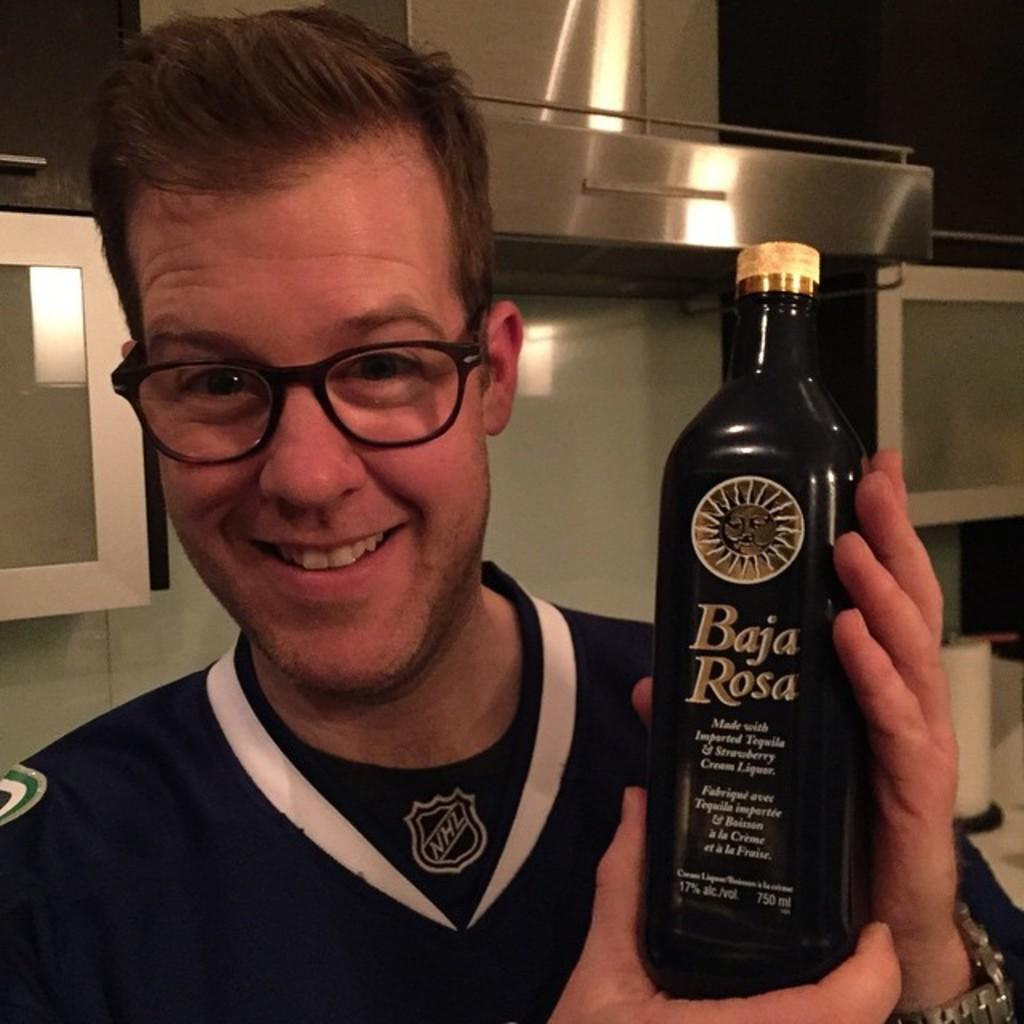Provide a one-sentence caption for the provided image. Guy in a hockey jersey holding a bottle of Baja Rosa. 